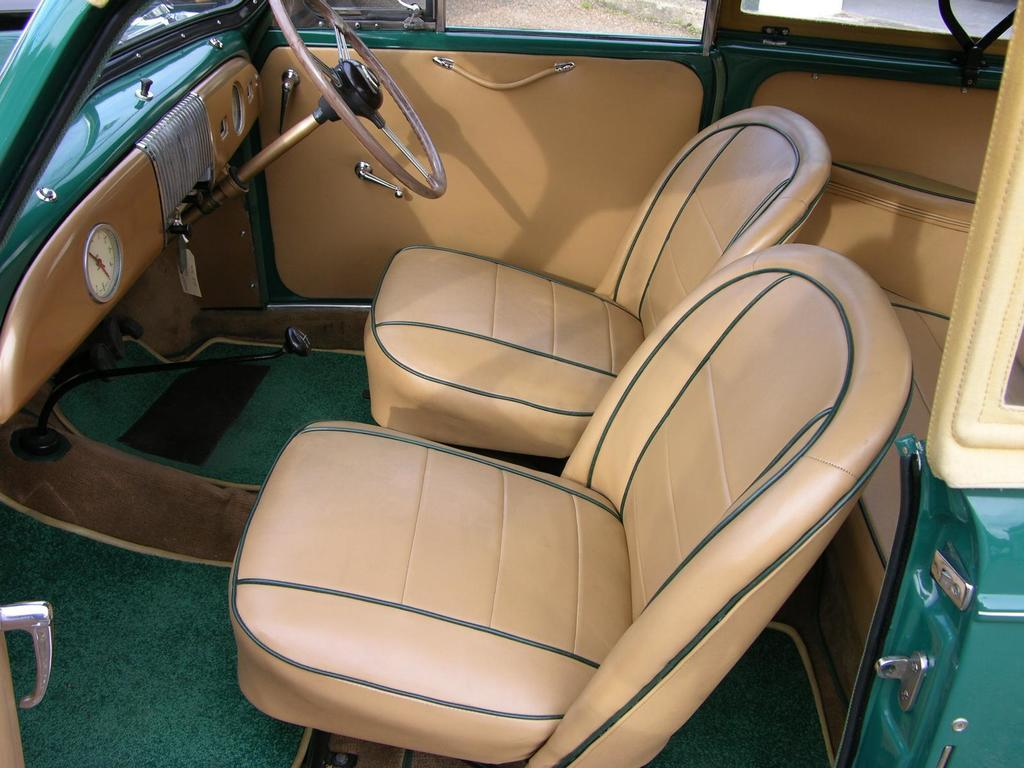What type of space is depicted in the image? The image shows the inside view of a vehicle. What can be found inside the vehicle? There are seats, a steering wheel, and a gear lever in the vehicle. What type of teeth can be seen in the image? There are no teeth visible in the image, as it features the interior of a vehicle. 